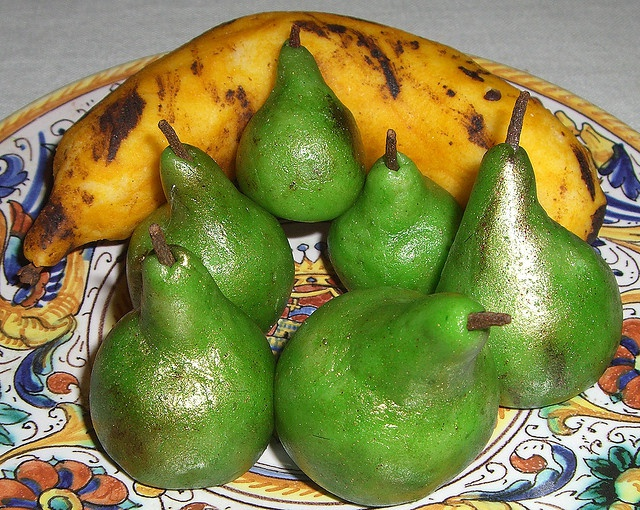Describe the objects in this image and their specific colors. I can see a banana in gray, orange, olive, maroon, and black tones in this image. 